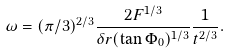<formula> <loc_0><loc_0><loc_500><loc_500>\omega = ( \pi / 3 ) ^ { 2 / 3 } \frac { 2 F ^ { 1 / 3 } } { \delta r ( \tan { \Phi _ { 0 } } ) ^ { 1 / 3 } } \frac { 1 } { t ^ { 2 / 3 } } .</formula> 